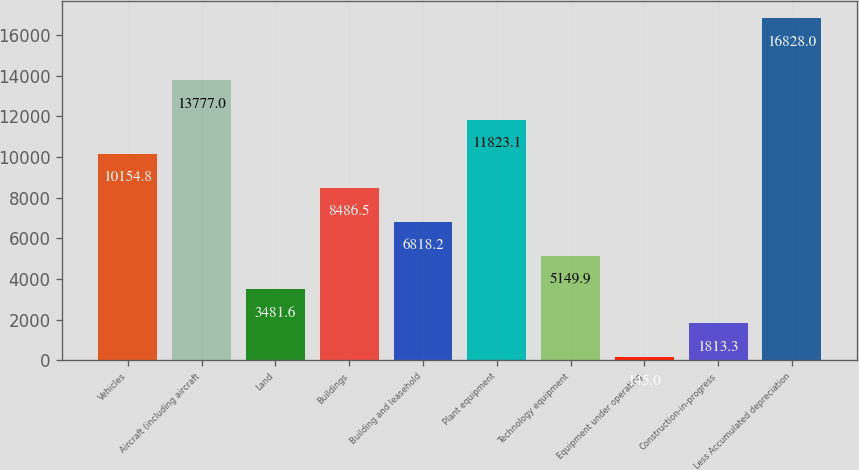Convert chart. <chart><loc_0><loc_0><loc_500><loc_500><bar_chart><fcel>Vehicles<fcel>Aircraft (including aircraft<fcel>Land<fcel>Buildings<fcel>Building and leasehold<fcel>Plant equipment<fcel>Technology equipment<fcel>Equipment under operating<fcel>Construction-in-progress<fcel>Less Accumulated depreciation<nl><fcel>10154.8<fcel>13777<fcel>3481.6<fcel>8486.5<fcel>6818.2<fcel>11823.1<fcel>5149.9<fcel>145<fcel>1813.3<fcel>16828<nl></chart> 